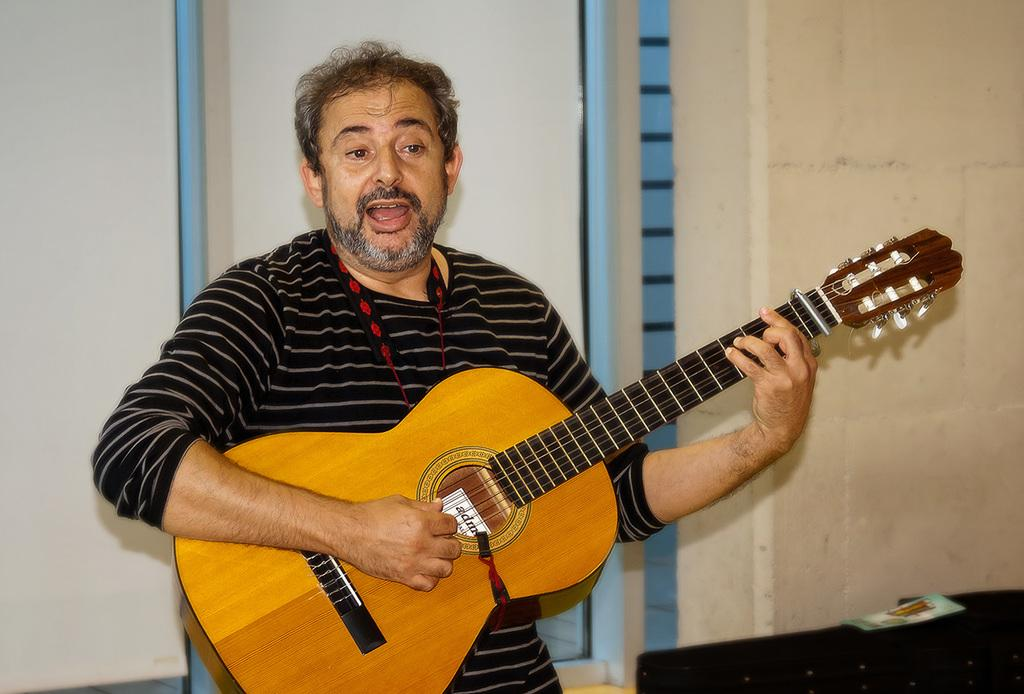Who is the main subject in the image? There is a man in the center of the image. What is the man doing in the image? The man is standing, playing a guitar, and singing a song. What can be seen in the background of the image? There is a window and a wall in the background of the image. How many mice are playing the guitar in the image? There are no mice present in the image, and therefore no mice are playing the guitar. 